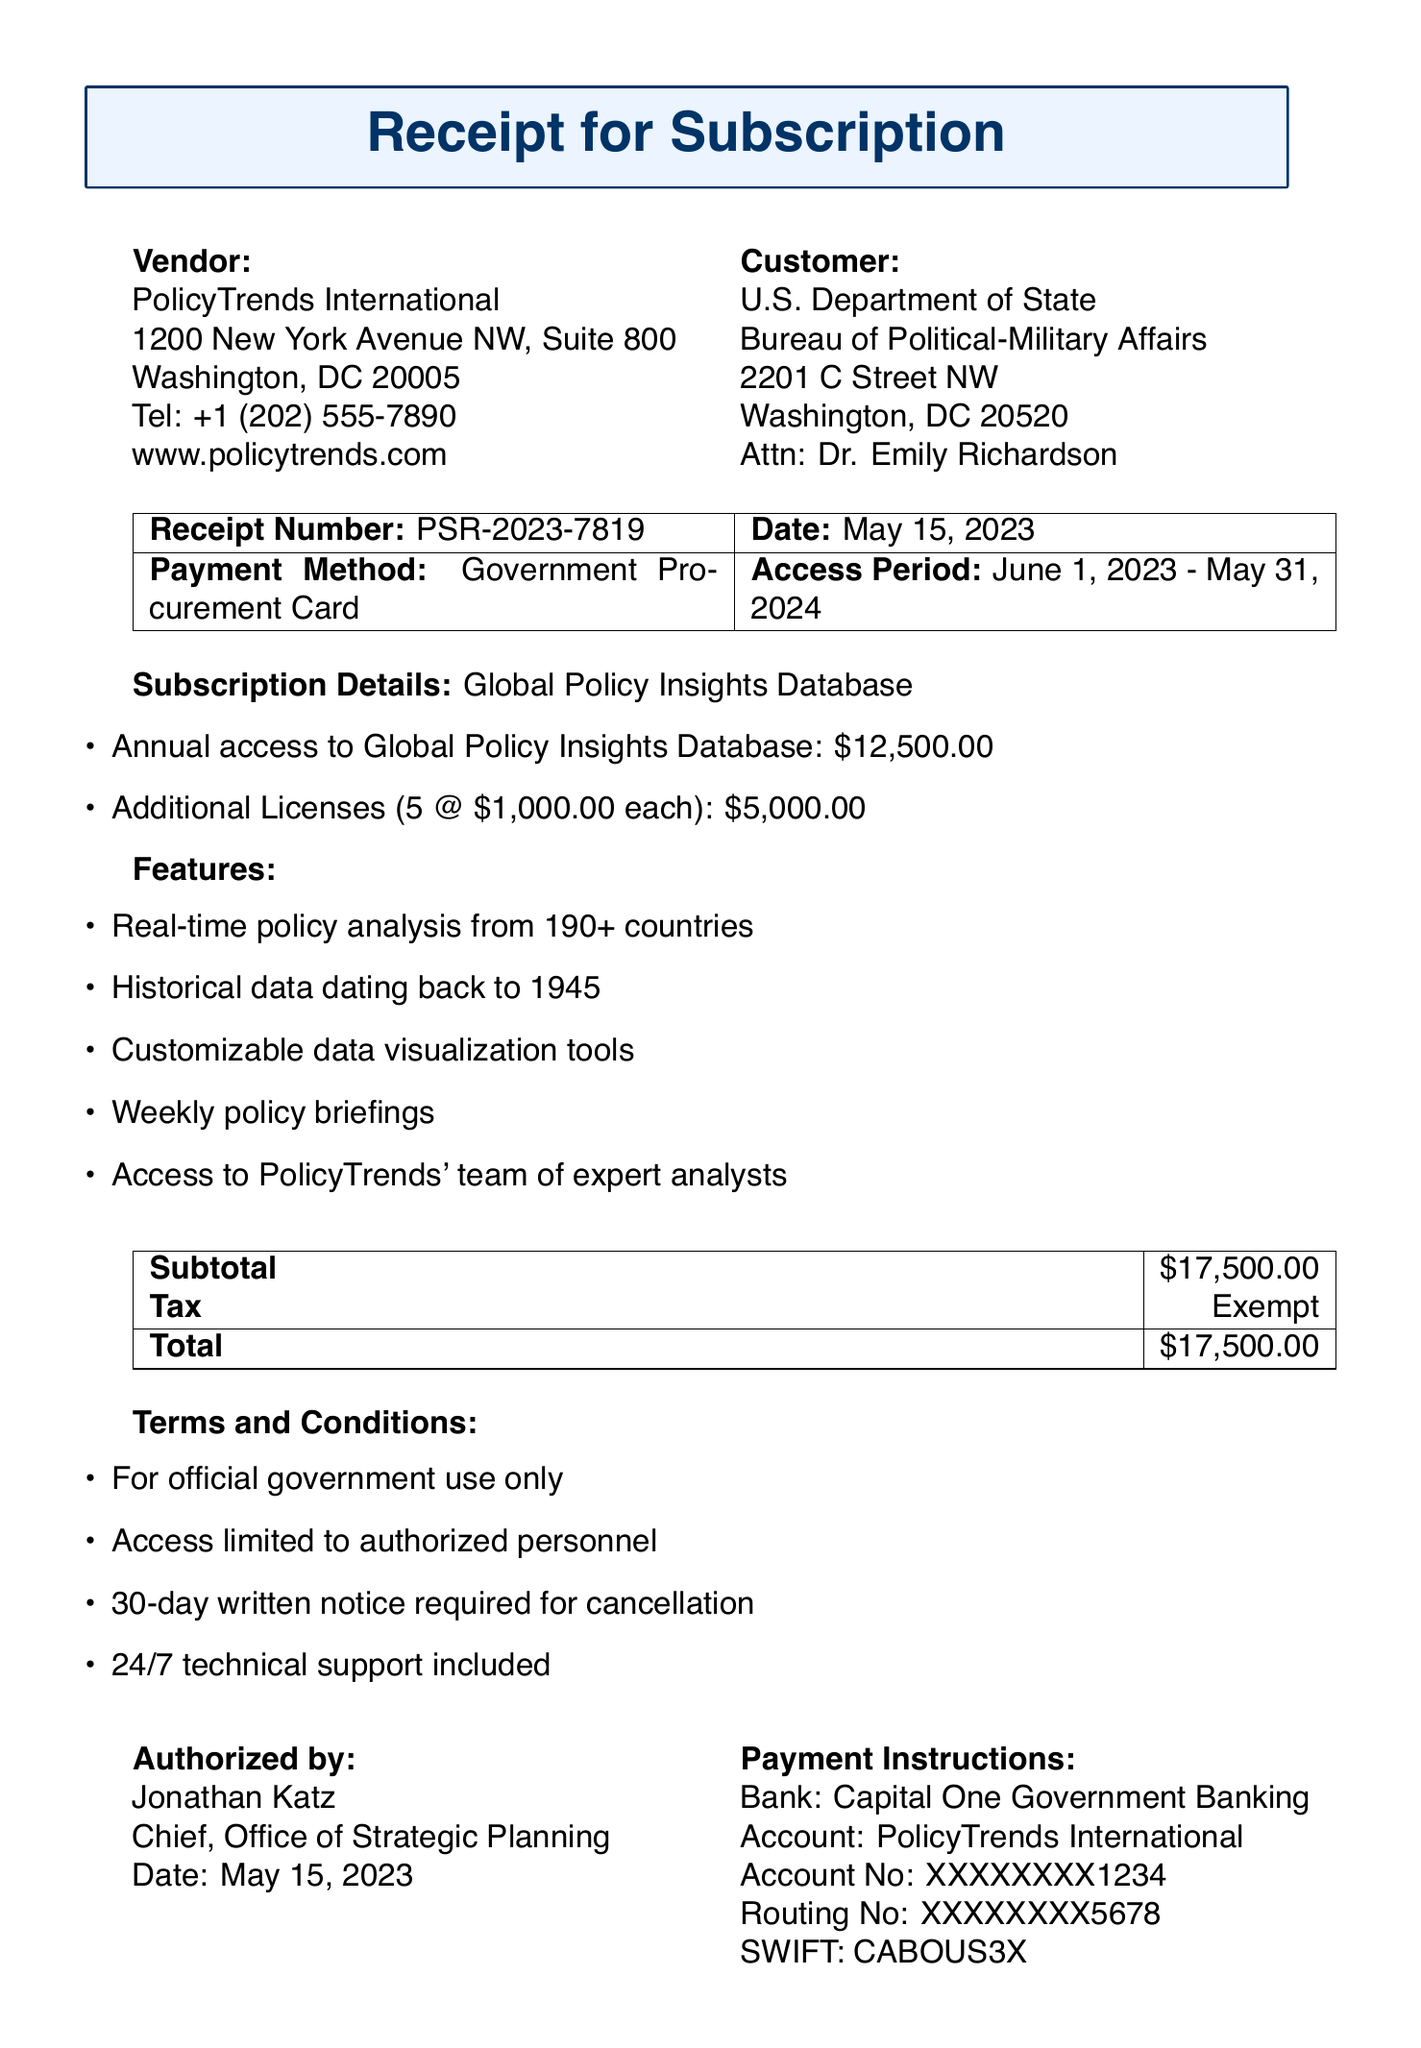What is the receipt number? The receipt number is a unique identifier for the transaction, listed as PSR-2023-7819.
Answer: PSR-2023-7819 What is the total amount due for the subscription? The total amount is summarized in the pricing breakdown section, which indicates $17,500.00 as the total.
Answer: $17,500.00 How long is the access period for the subscription? The access period is stated explicitly, which is from June 1, 2023, to May 31, 2024.
Answer: June 1, 2023 - May 31, 2024 Who is the authorized signer for this document? The authorized signer is detailed in the document under “Authorized by,” specifically Jonathan Katz.
Answer: Jonathan Katz What is the price per additional license? The price for each additional license is specified in the subscription details as $1,000.00.
Answer: $1,000.00 What is the cancellation policy stated in the document? The cancellation policy is outlined in the terms and conditions, requiring a 30-day written notice for cancellation.
Answer: 30-day written notice required for cancellation How many additional licenses were purchased? The quantity of additional licenses is provided in the subscription details, which is 5.
Answer: 5 What features are included with the subscription? The document lists several features, including customizable data visualization tools and weekly policy briefings.
Answer: Real-time policy analysis from 190+ countries, Historical data dating back to 1945, Customizable data visualization tools, Weekly policy briefings, Access to PolicyTrends' team of expert analysts What is the payment method used for this transaction? The payment method is explicitly mentioned in the receipt details as Government Procurement Card.
Answer: Government Procurement Card 